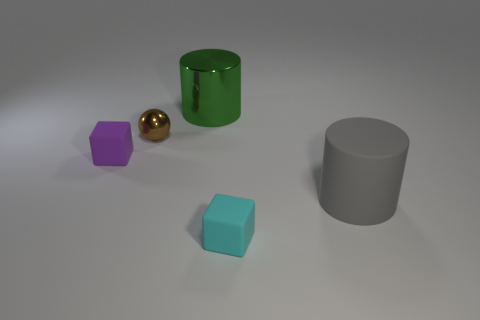Do the large metallic cylinder and the sphere have the same color?
Keep it short and to the point. No. What number of blocks are either big red metal things or big objects?
Give a very brief answer. 0. What is the color of the large cylinder that is in front of the small rubber block that is to the left of the small cyan thing?
Provide a short and direct response. Gray. How many green things are behind the small matte block that is behind the small rubber block that is on the right side of the small brown sphere?
Ensure brevity in your answer.  1. Is the shape of the large object right of the tiny cyan rubber block the same as the metal object that is to the left of the large shiny cylinder?
Offer a terse response. No. What number of things are tiny purple things or matte balls?
Your answer should be very brief. 1. There is a tiny brown sphere that is in front of the big thing that is behind the gray matte cylinder; what is its material?
Ensure brevity in your answer.  Metal. Is there a small rubber object that has the same color as the large metal object?
Offer a very short reply. No. What is the color of the other block that is the same size as the purple cube?
Your answer should be very brief. Cyan. There is a cube left of the small rubber thing that is in front of the rubber object that is on the right side of the small cyan thing; what is it made of?
Make the answer very short. Rubber. 